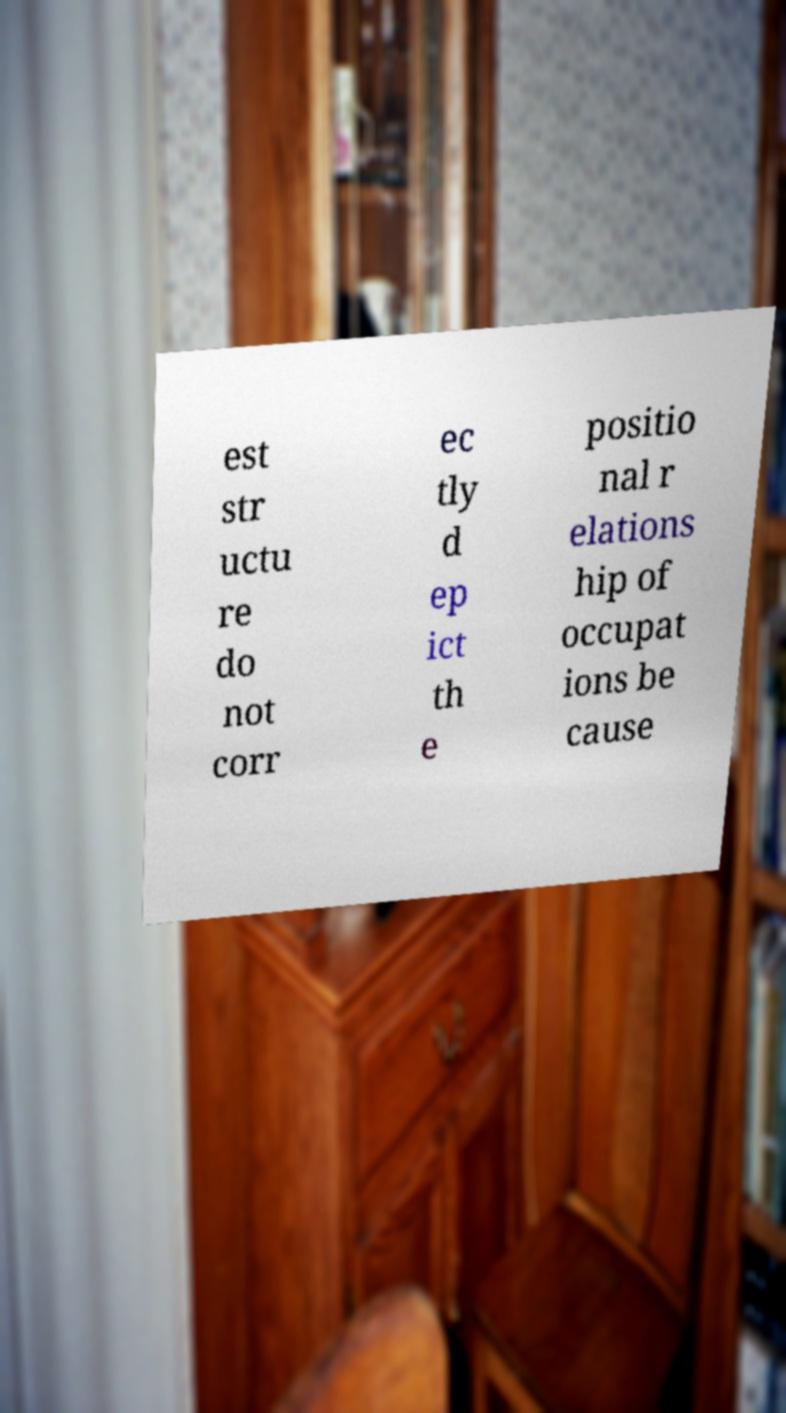I need the written content from this picture converted into text. Can you do that? est str uctu re do not corr ec tly d ep ict th e positio nal r elations hip of occupat ions be cause 